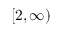Convert formula to latex. <formula><loc_0><loc_0><loc_500><loc_500>[ 2 , \infty )</formula> 